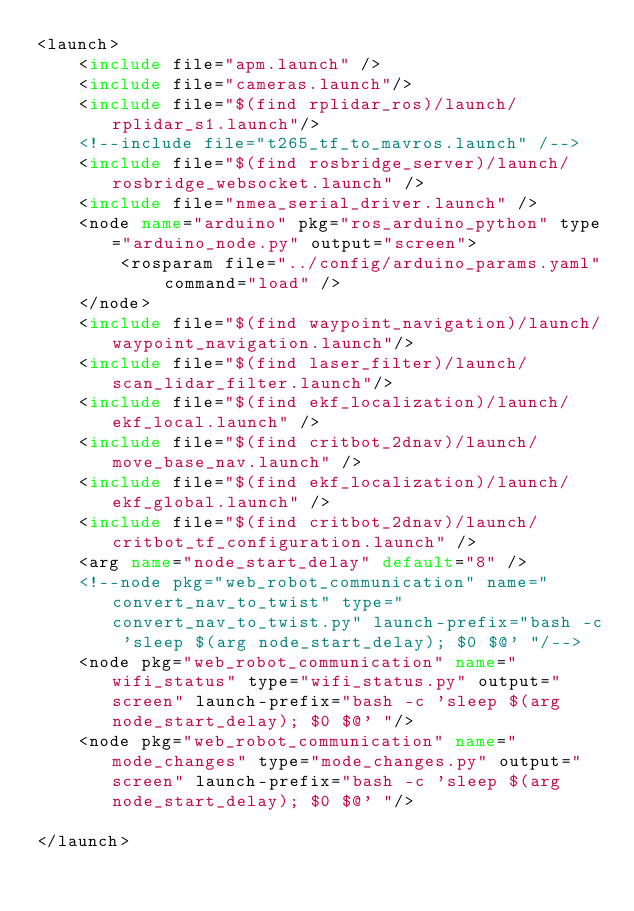Convert code to text. <code><loc_0><loc_0><loc_500><loc_500><_XML_><launch>
    <include file="apm.launch" />
    <include file="cameras.launch"/>
    <include file="$(find rplidar_ros)/launch/rplidar_s1.launch"/>
    <!--include file="t265_tf_to_mavros.launch" /-->
    <include file="$(find rosbridge_server)/launch/rosbridge_websocket.launch" />
    <include file="nmea_serial_driver.launch" />
    <node name="arduino" pkg="ros_arduino_python" type="arduino_node.py" output="screen">
        <rosparam file="../config/arduino_params.yaml" command="load" />
    </node>
    <include file="$(find waypoint_navigation)/launch/waypoint_navigation.launch"/>
    <include file="$(find laser_filter)/launch/scan_lidar_filter.launch"/>
    <include file="$(find ekf_localization)/launch/ekf_local.launch" />
    <include file="$(find critbot_2dnav)/launch/move_base_nav.launch" />
    <include file="$(find ekf_localization)/launch/ekf_global.launch" />
    <include file="$(find critbot_2dnav)/launch/critbot_tf_configuration.launch" />
    <arg name="node_start_delay" default="8" /> 
    <!--node pkg="web_robot_communication" name="convert_nav_to_twist" type="convert_nav_to_twist.py" launch-prefix="bash -c 'sleep $(arg node_start_delay); $0 $@' "/-->
    <node pkg="web_robot_communication" name="wifi_status" type="wifi_status.py" output="screen" launch-prefix="bash -c 'sleep $(arg node_start_delay); $0 $@' "/>
    <node pkg="web_robot_communication" name="mode_changes" type="mode_changes.py" output="screen" launch-prefix="bash -c 'sleep $(arg node_start_delay); $0 $@' "/>
    
</launch>
</code> 